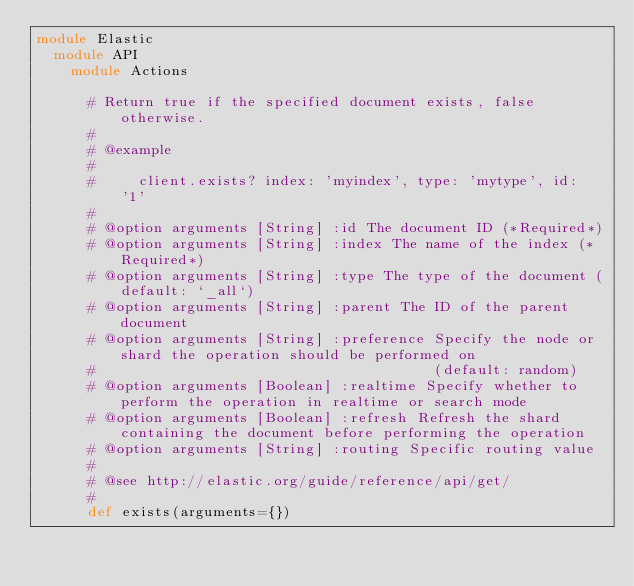Convert code to text. <code><loc_0><loc_0><loc_500><loc_500><_Ruby_>module Elastic
  module API
    module Actions

      # Return true if the specified document exists, false otherwise.
      #
      # @example
      #
      #     client.exists? index: 'myindex', type: 'mytype', id: '1'
      #
      # @option arguments [String] :id The document ID (*Required*)
      # @option arguments [String] :index The name of the index (*Required*)
      # @option arguments [String] :type The type of the document (default: `_all`)
      # @option arguments [String] :parent The ID of the parent document
      # @option arguments [String] :preference Specify the node or shard the operation should be performed on
      #                                        (default: random)
      # @option arguments [Boolean] :realtime Specify whether to perform the operation in realtime or search mode
      # @option arguments [Boolean] :refresh Refresh the shard containing the document before performing the operation
      # @option arguments [String] :routing Specific routing value
      #
      # @see http://elastic.org/guide/reference/api/get/
      #
      def exists(arguments={})</code> 